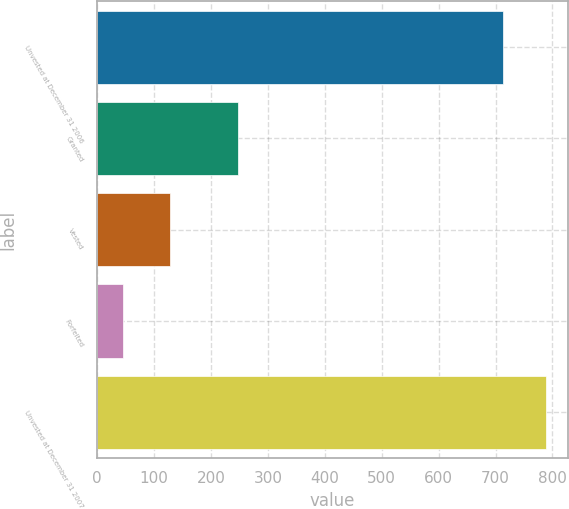<chart> <loc_0><loc_0><loc_500><loc_500><bar_chart><fcel>Unvested at December 31 2006<fcel>Granted<fcel>Vested<fcel>Forfeited<fcel>Unvested at December 31 2007<nl><fcel>713<fcel>248<fcel>128<fcel>45<fcel>788<nl></chart> 